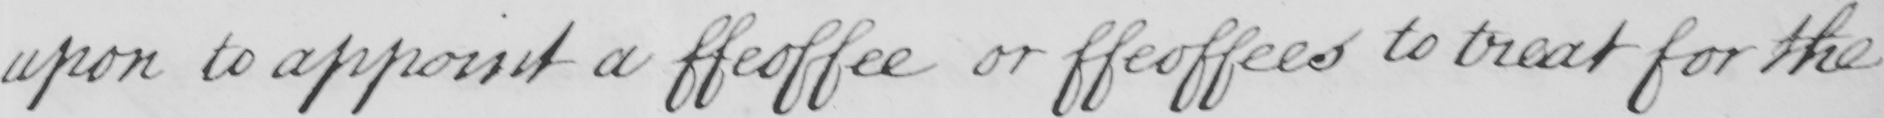Please provide the text content of this handwritten line. upon to appoint a ffeoffee or ffeoffees to treat for the 